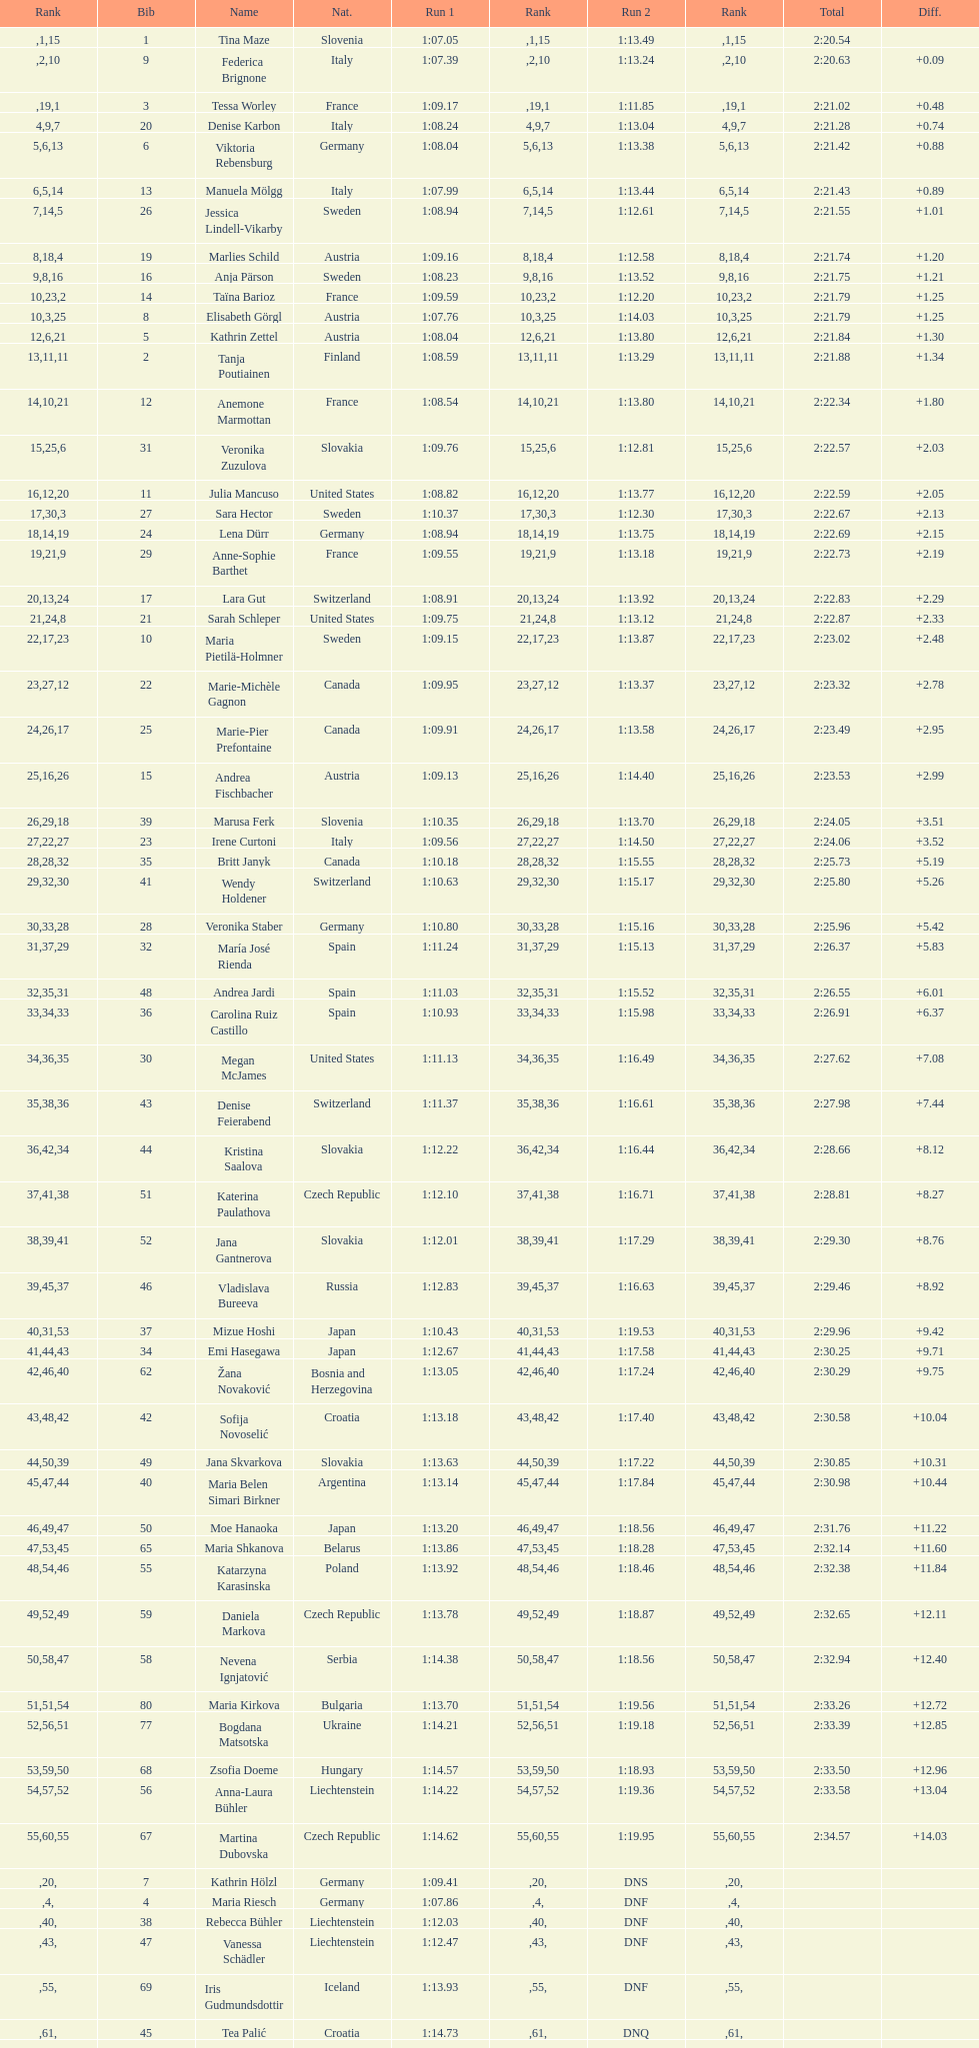Which competitor was the last one to finish both runs? Martina Dubovska. 